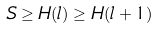<formula> <loc_0><loc_0><loc_500><loc_500>S \geq H ( l ) \geq H ( l + 1 )</formula> 